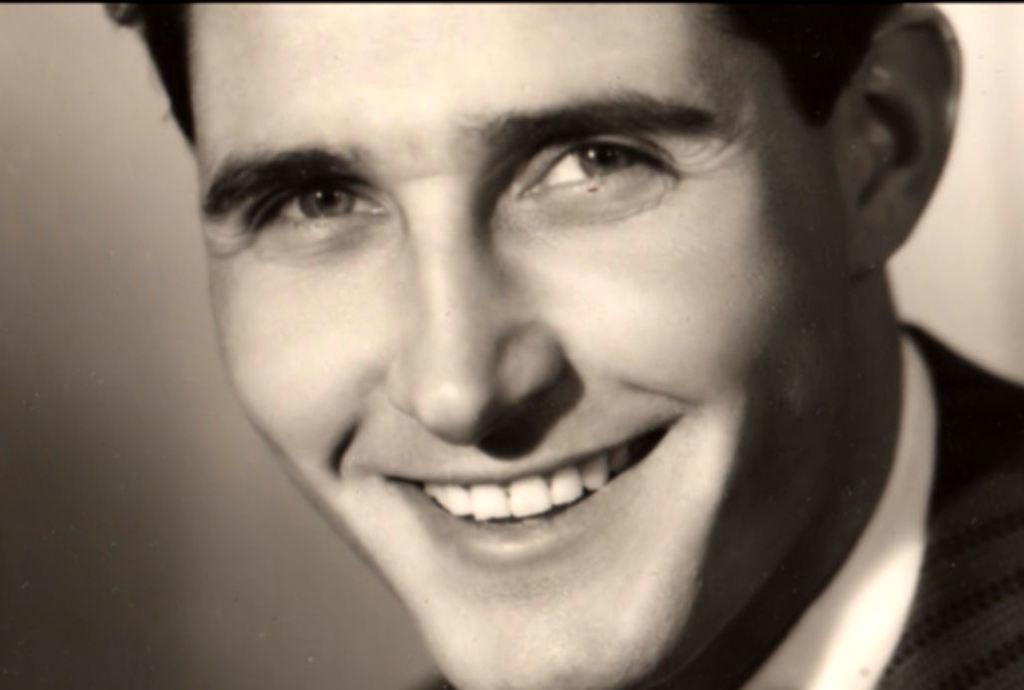Please provide a concise description of this image. In this image I can see the person and the image is in black and white. 